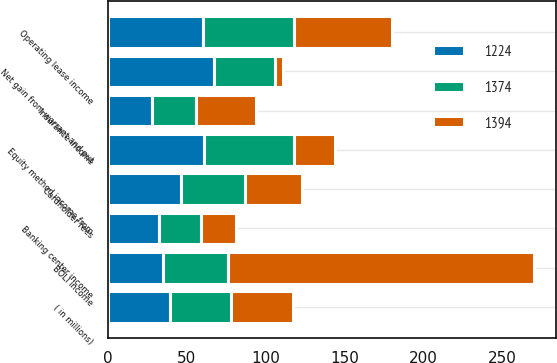<chart> <loc_0><loc_0><loc_500><loc_500><stacked_bar_chart><ecel><fcel>( in millions)<fcel>Net gain from warrant and put<fcel>Equity method income from<fcel>Operating lease income<fcel>Cardholder fees<fcel>BOLI income<fcel>Banking center income<fcel>Insurance income<nl><fcel>1224<fcel>39<fcel>67<fcel>61<fcel>60<fcel>46<fcel>35<fcel>32<fcel>28<nl><fcel>1374<fcel>39<fcel>39<fcel>57<fcel>58<fcel>41<fcel>41<fcel>27<fcel>28<nl><fcel>1394<fcel>39<fcel>5<fcel>26<fcel>62<fcel>36<fcel>194<fcel>22<fcel>38<nl></chart> 